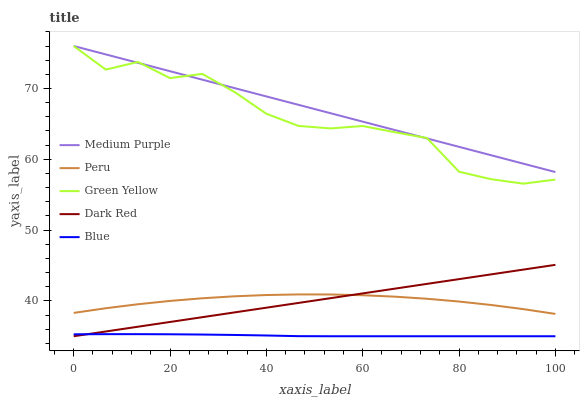Does Blue have the minimum area under the curve?
Answer yes or no. Yes. Does Medium Purple have the maximum area under the curve?
Answer yes or no. Yes. Does Dark Red have the minimum area under the curve?
Answer yes or no. No. Does Dark Red have the maximum area under the curve?
Answer yes or no. No. Is Dark Red the smoothest?
Answer yes or no. Yes. Is Green Yellow the roughest?
Answer yes or no. Yes. Is Green Yellow the smoothest?
Answer yes or no. No. Is Dark Red the roughest?
Answer yes or no. No. Does Green Yellow have the lowest value?
Answer yes or no. No. Does Green Yellow have the highest value?
Answer yes or no. Yes. Does Dark Red have the highest value?
Answer yes or no. No. Is Blue less than Green Yellow?
Answer yes or no. Yes. Is Green Yellow greater than Peru?
Answer yes or no. Yes. Does Dark Red intersect Blue?
Answer yes or no. Yes. Is Dark Red less than Blue?
Answer yes or no. No. Is Dark Red greater than Blue?
Answer yes or no. No. Does Blue intersect Green Yellow?
Answer yes or no. No. 